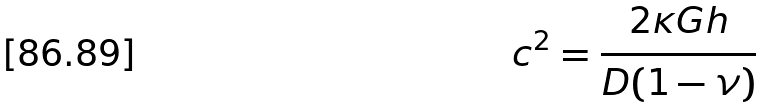<formula> <loc_0><loc_0><loc_500><loc_500>c ^ { 2 } = \frac { 2 \kappa G h } { D ( 1 - \nu ) }</formula> 